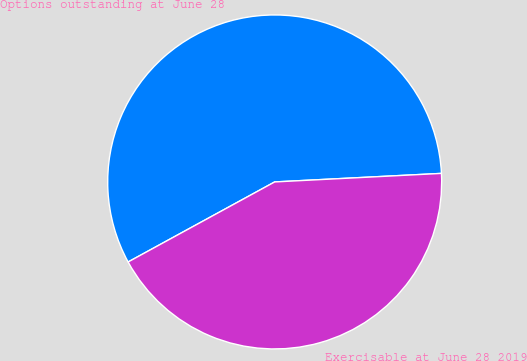<chart> <loc_0><loc_0><loc_500><loc_500><pie_chart><fcel>Options outstanding at June 28<fcel>Exercisable at June 28 2019<nl><fcel>57.14%<fcel>42.86%<nl></chart> 